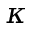Convert formula to latex. <formula><loc_0><loc_0><loc_500><loc_500>\kappa</formula> 